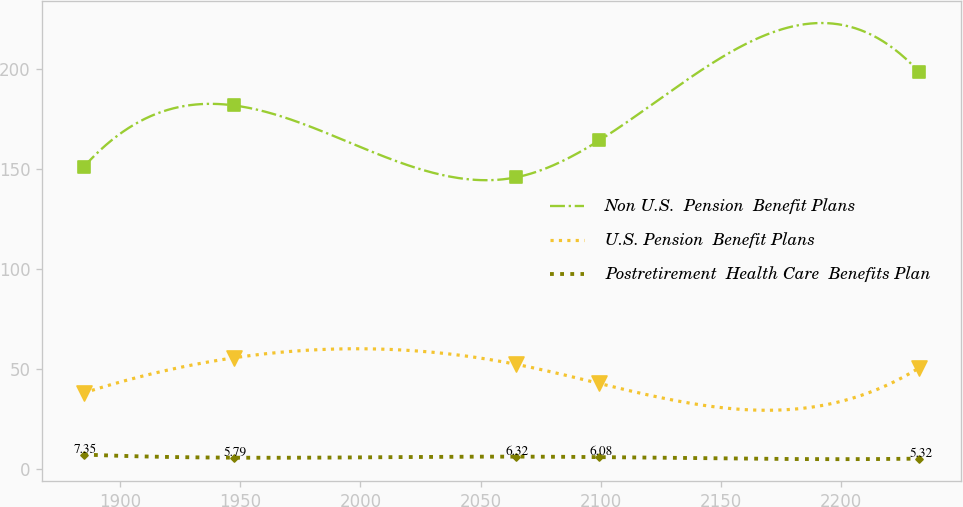<chart> <loc_0><loc_0><loc_500><loc_500><line_chart><ecel><fcel>Non U.S.  Pension  Benefit Plans<fcel>U.S. Pension  Benefit Plans<fcel>Postretirement  Health Care  Benefits Plan<nl><fcel>1884.97<fcel>151.14<fcel>38.16<fcel>7.35<nl><fcel>1947.28<fcel>181.87<fcel>55.68<fcel>5.79<nl><fcel>2064.69<fcel>145.89<fcel>52.48<fcel>6.32<nl><fcel>2099.45<fcel>164.39<fcel>42.88<fcel>6.08<nl><fcel>2232.54<fcel>198.4<fcel>50.73<fcel>5.32<nl></chart> 